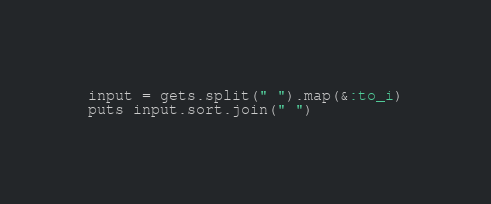Convert code to text. <code><loc_0><loc_0><loc_500><loc_500><_Ruby_>input = gets.split(" ").map(&:to_i)
puts input.sort.join(" ")
</code> 